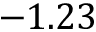<formula> <loc_0><loc_0><loc_500><loc_500>- 1 . 2 3</formula> 